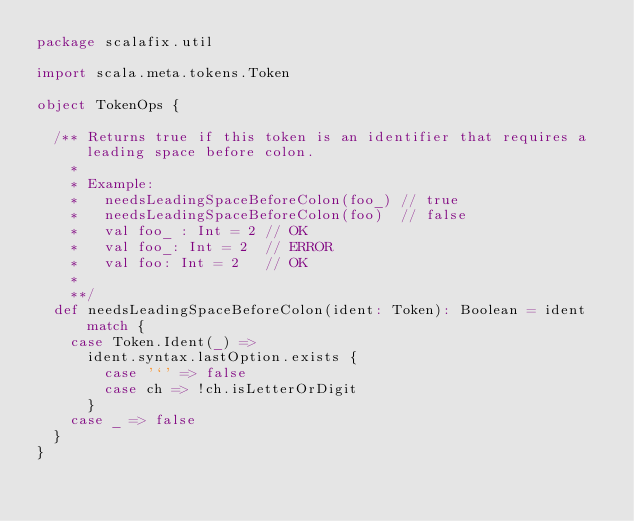Convert code to text. <code><loc_0><loc_0><loc_500><loc_500><_Scala_>package scalafix.util

import scala.meta.tokens.Token

object TokenOps {

  /** Returns true if this token is an identifier that requires a leading space before colon.
    *
    * Example:
    *   needsLeadingSpaceBeforeColon(foo_) // true
    *   needsLeadingSpaceBeforeColon(foo)  // false
    *   val foo_ : Int = 2 // OK
    *   val foo_: Int = 2  // ERROR
    *   val foo: Int = 2   // OK
    *
    **/
  def needsLeadingSpaceBeforeColon(ident: Token): Boolean = ident match {
    case Token.Ident(_) =>
      ident.syntax.lastOption.exists {
        case '`' => false
        case ch => !ch.isLetterOrDigit
      }
    case _ => false
  }
}
</code> 